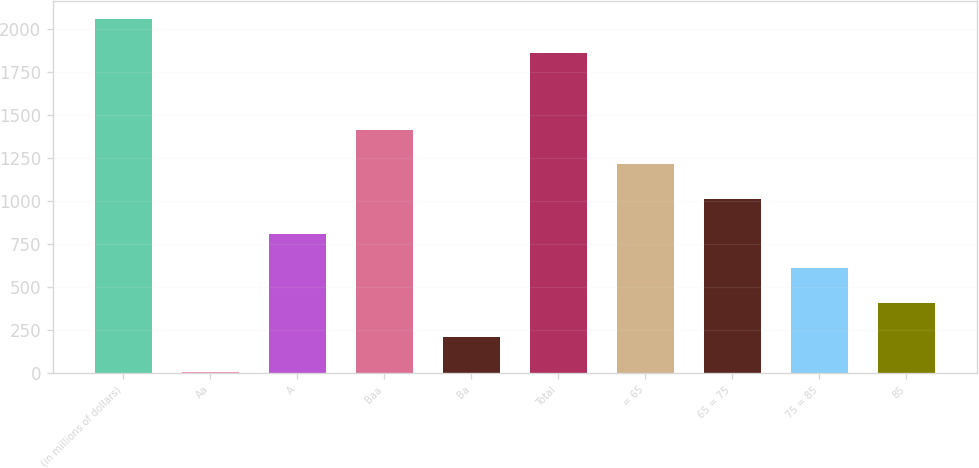Convert chart. <chart><loc_0><loc_0><loc_500><loc_500><bar_chart><fcel>(in millions of dollars)<fcel>Aa<fcel>A<fcel>Baa<fcel>Ba<fcel>Total<fcel>= 65<fcel>65 = 75<fcel>75 = 85<fcel>85<nl><fcel>2057.23<fcel>7.7<fcel>810.22<fcel>1412.11<fcel>208.33<fcel>1856.6<fcel>1211.48<fcel>1010.85<fcel>609.59<fcel>408.96<nl></chart> 